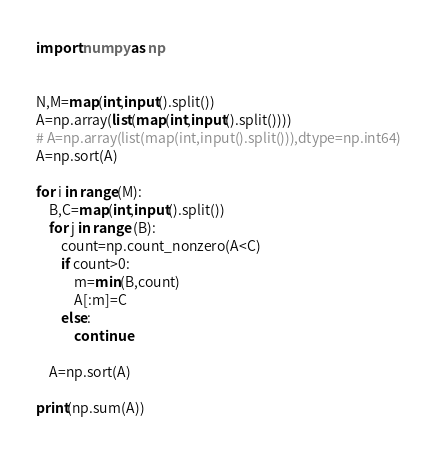Convert code to text. <code><loc_0><loc_0><loc_500><loc_500><_Python_>import numpy as np


N,M=map(int,input().split())
A=np.array(list(map(int,input().split())))
# A=np.array(list(map(int,input().split())),dtype=np.int64)
A=np.sort(A)

for i in range(M):
    B,C=map(int,input().split())
    for j in range (B):
        count=np.count_nonzero(A<C)
        if count>0:
            m=min(B,count)
            A[:m]=C
        else:
            continue
    
    A=np.sort(A)

print(np.sum(A))</code> 